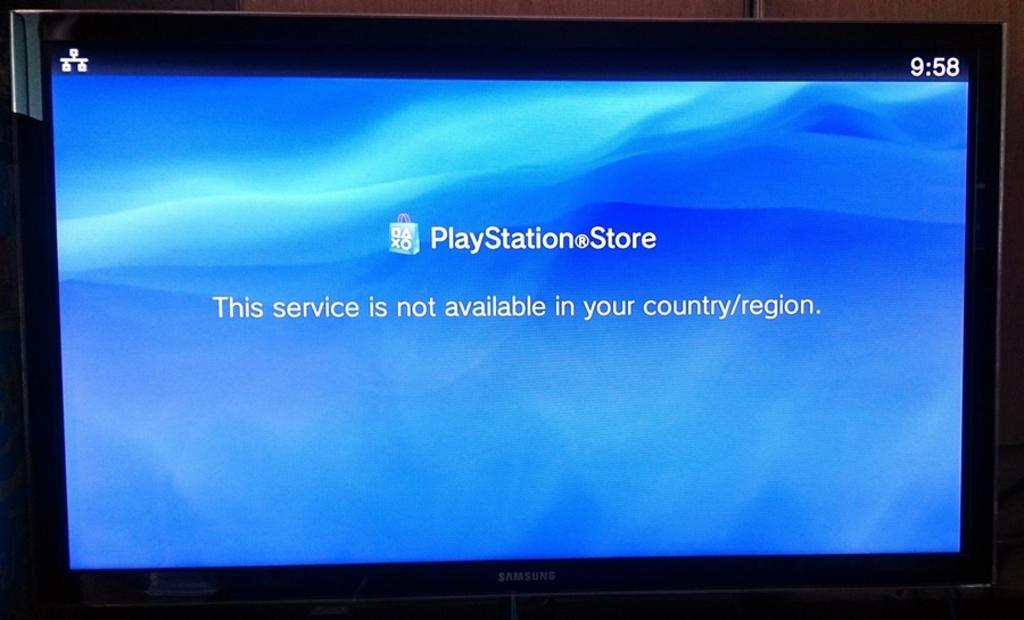<image>
Write a terse but informative summary of the picture. A Samsung screen displays The Playstation Store with a message that reads "this service is not available in your country/region" 